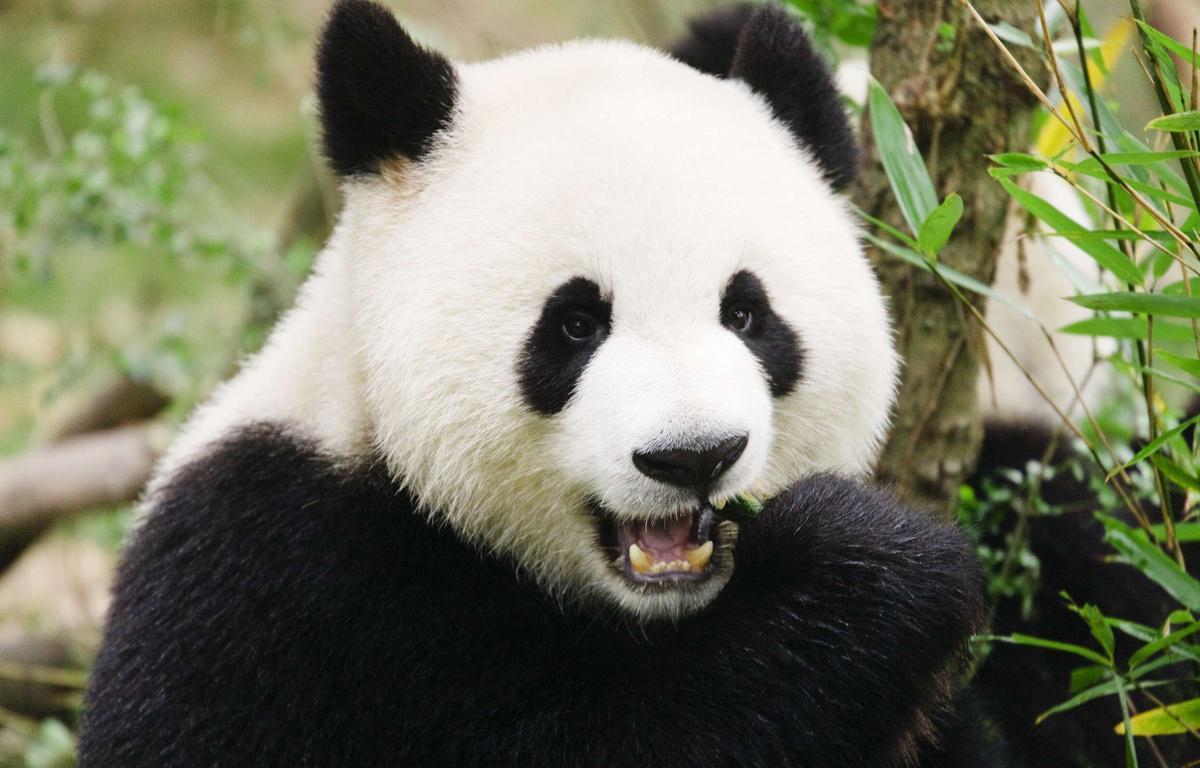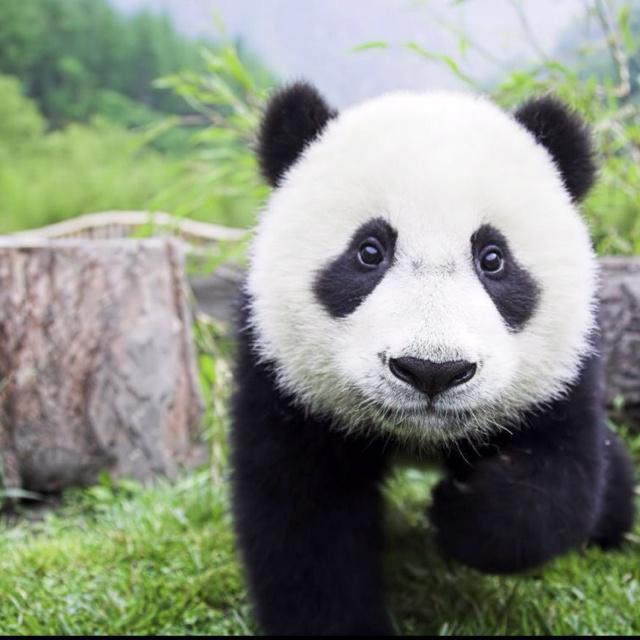The first image is the image on the left, the second image is the image on the right. Analyze the images presented: Is the assertion "The panda on the left is nibbling a green stick without leaves on it." valid? Answer yes or no. Yes. 